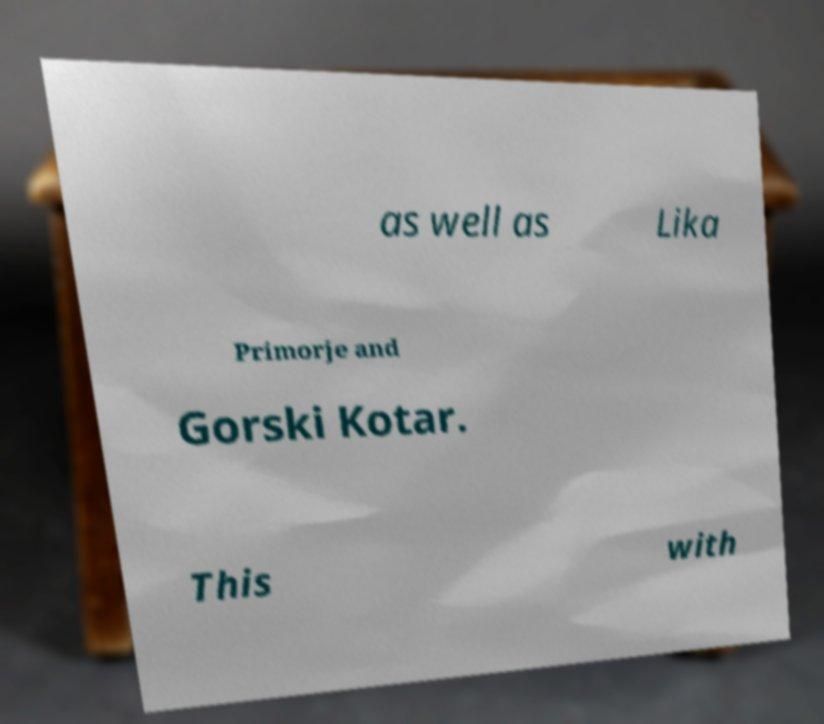For documentation purposes, I need the text within this image transcribed. Could you provide that? as well as Lika Primorje and Gorski Kotar. This with 